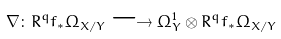Convert formula to latex. <formula><loc_0><loc_0><loc_500><loc_500>\nabla \colon R ^ { q } f _ { \ast } \Omega _ { X / Y } \longrightarrow \Omega _ { Y } ^ { 1 } \otimes R ^ { q } f _ { \ast } \Omega _ { X / Y }</formula> 